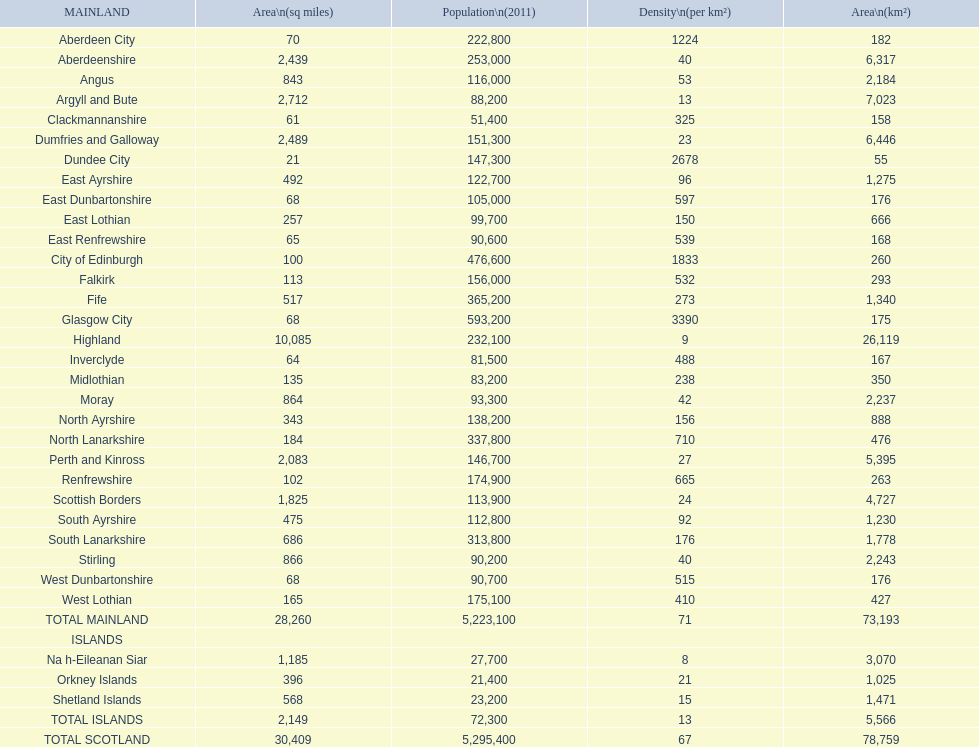Which mainland has the least population? Clackmannanshire. 